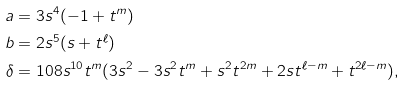Convert formula to latex. <formula><loc_0><loc_0><loc_500><loc_500>a & = 3 s ^ { 4 } ( - 1 + t ^ { m } ) \\ b & = 2 s ^ { 5 } ( s + t ^ { \ell } ) \\ \delta & = 1 0 8 s ^ { 1 0 } t ^ { m } ( 3 s ^ { 2 } - 3 s ^ { 2 } t ^ { m } + s ^ { 2 } t ^ { 2 m } + 2 s t ^ { \ell - m } + t ^ { 2 \ell - m } ) ,</formula> 